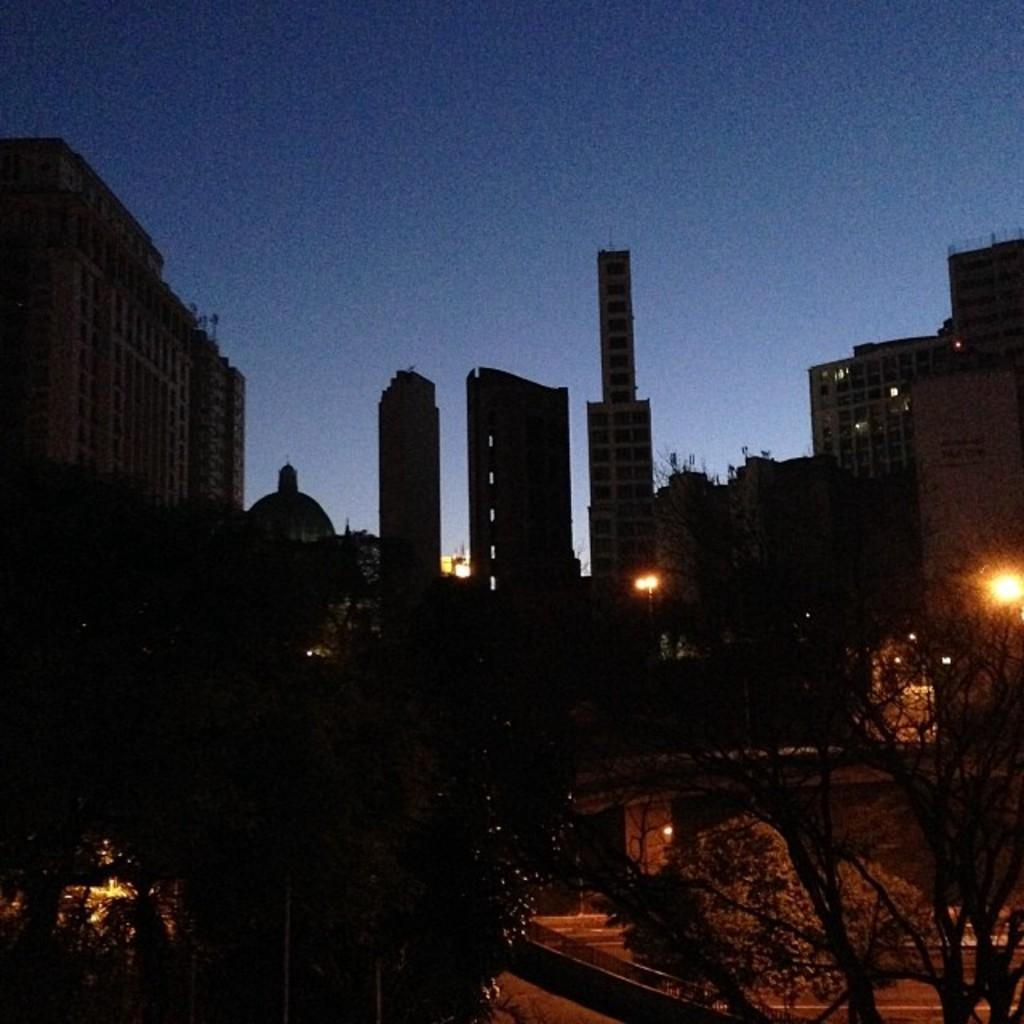What type of structures can be seen in the background of the image? There are buildings in the background of the image. What type of vegetation is present in the image? There are trees in the image. What is the distribution of the trees in the image? The question about the distribution of trees is not relevant to the image, as the facts provided do not give any information about the arrangement or distribution of the trees. 